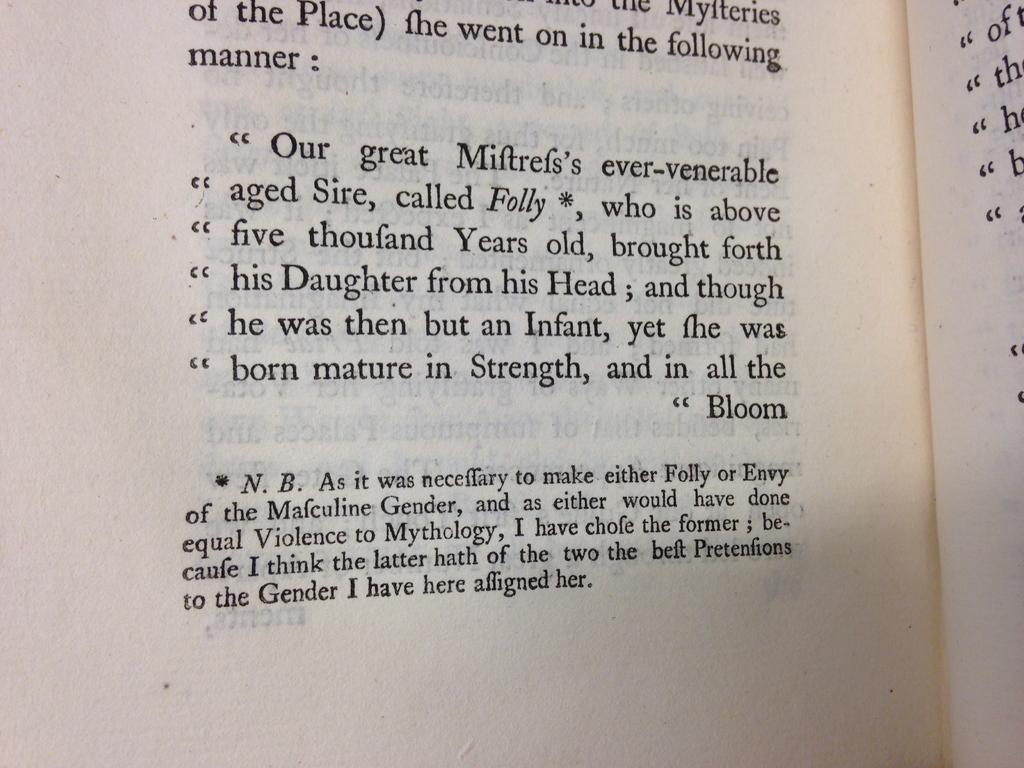How old is folly?
Your answer should be compact. Above five thousand years old. What is the last word on this page?
Your answer should be very brief. Her. 